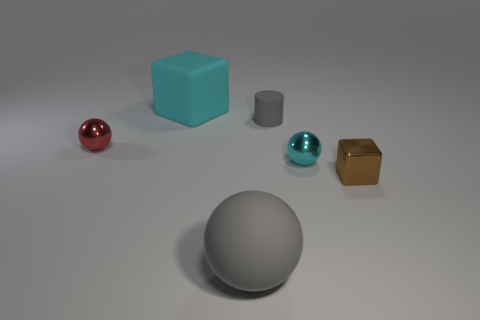There is a metallic object that is the same color as the big block; what is its size?
Your response must be concise. Small. The object that is the same color as the tiny cylinder is what shape?
Provide a short and direct response. Sphere. What number of tiny red metal things have the same shape as the big gray thing?
Ensure brevity in your answer.  1. How many shiny things are the same size as the cyan cube?
Keep it short and to the point. 0. What is the material of the gray thing that is the same shape as the small red metal thing?
Your response must be concise. Rubber. What color is the metallic ball that is on the right side of the small red sphere?
Your response must be concise. Cyan. Are there more matte spheres that are to the left of the big cyan matte object than metal cubes?
Your answer should be compact. No. The small metal block has what color?
Make the answer very short. Brown. There is a gray thing that is behind the tiny metallic ball right of the block on the left side of the small cyan shiny ball; what is its shape?
Give a very brief answer. Cylinder. What material is the tiny object that is both left of the cyan shiny thing and to the right of the big cube?
Provide a succinct answer. Rubber. 